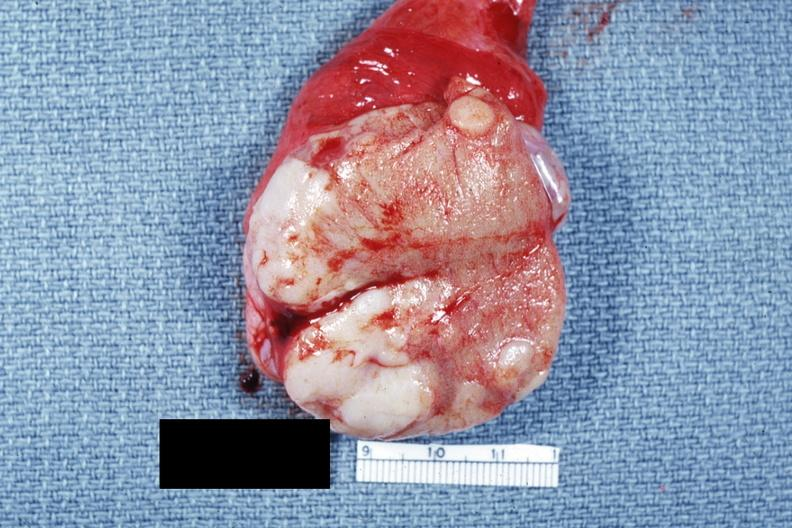s testicle present?
Answer the question using a single word or phrase. Yes 